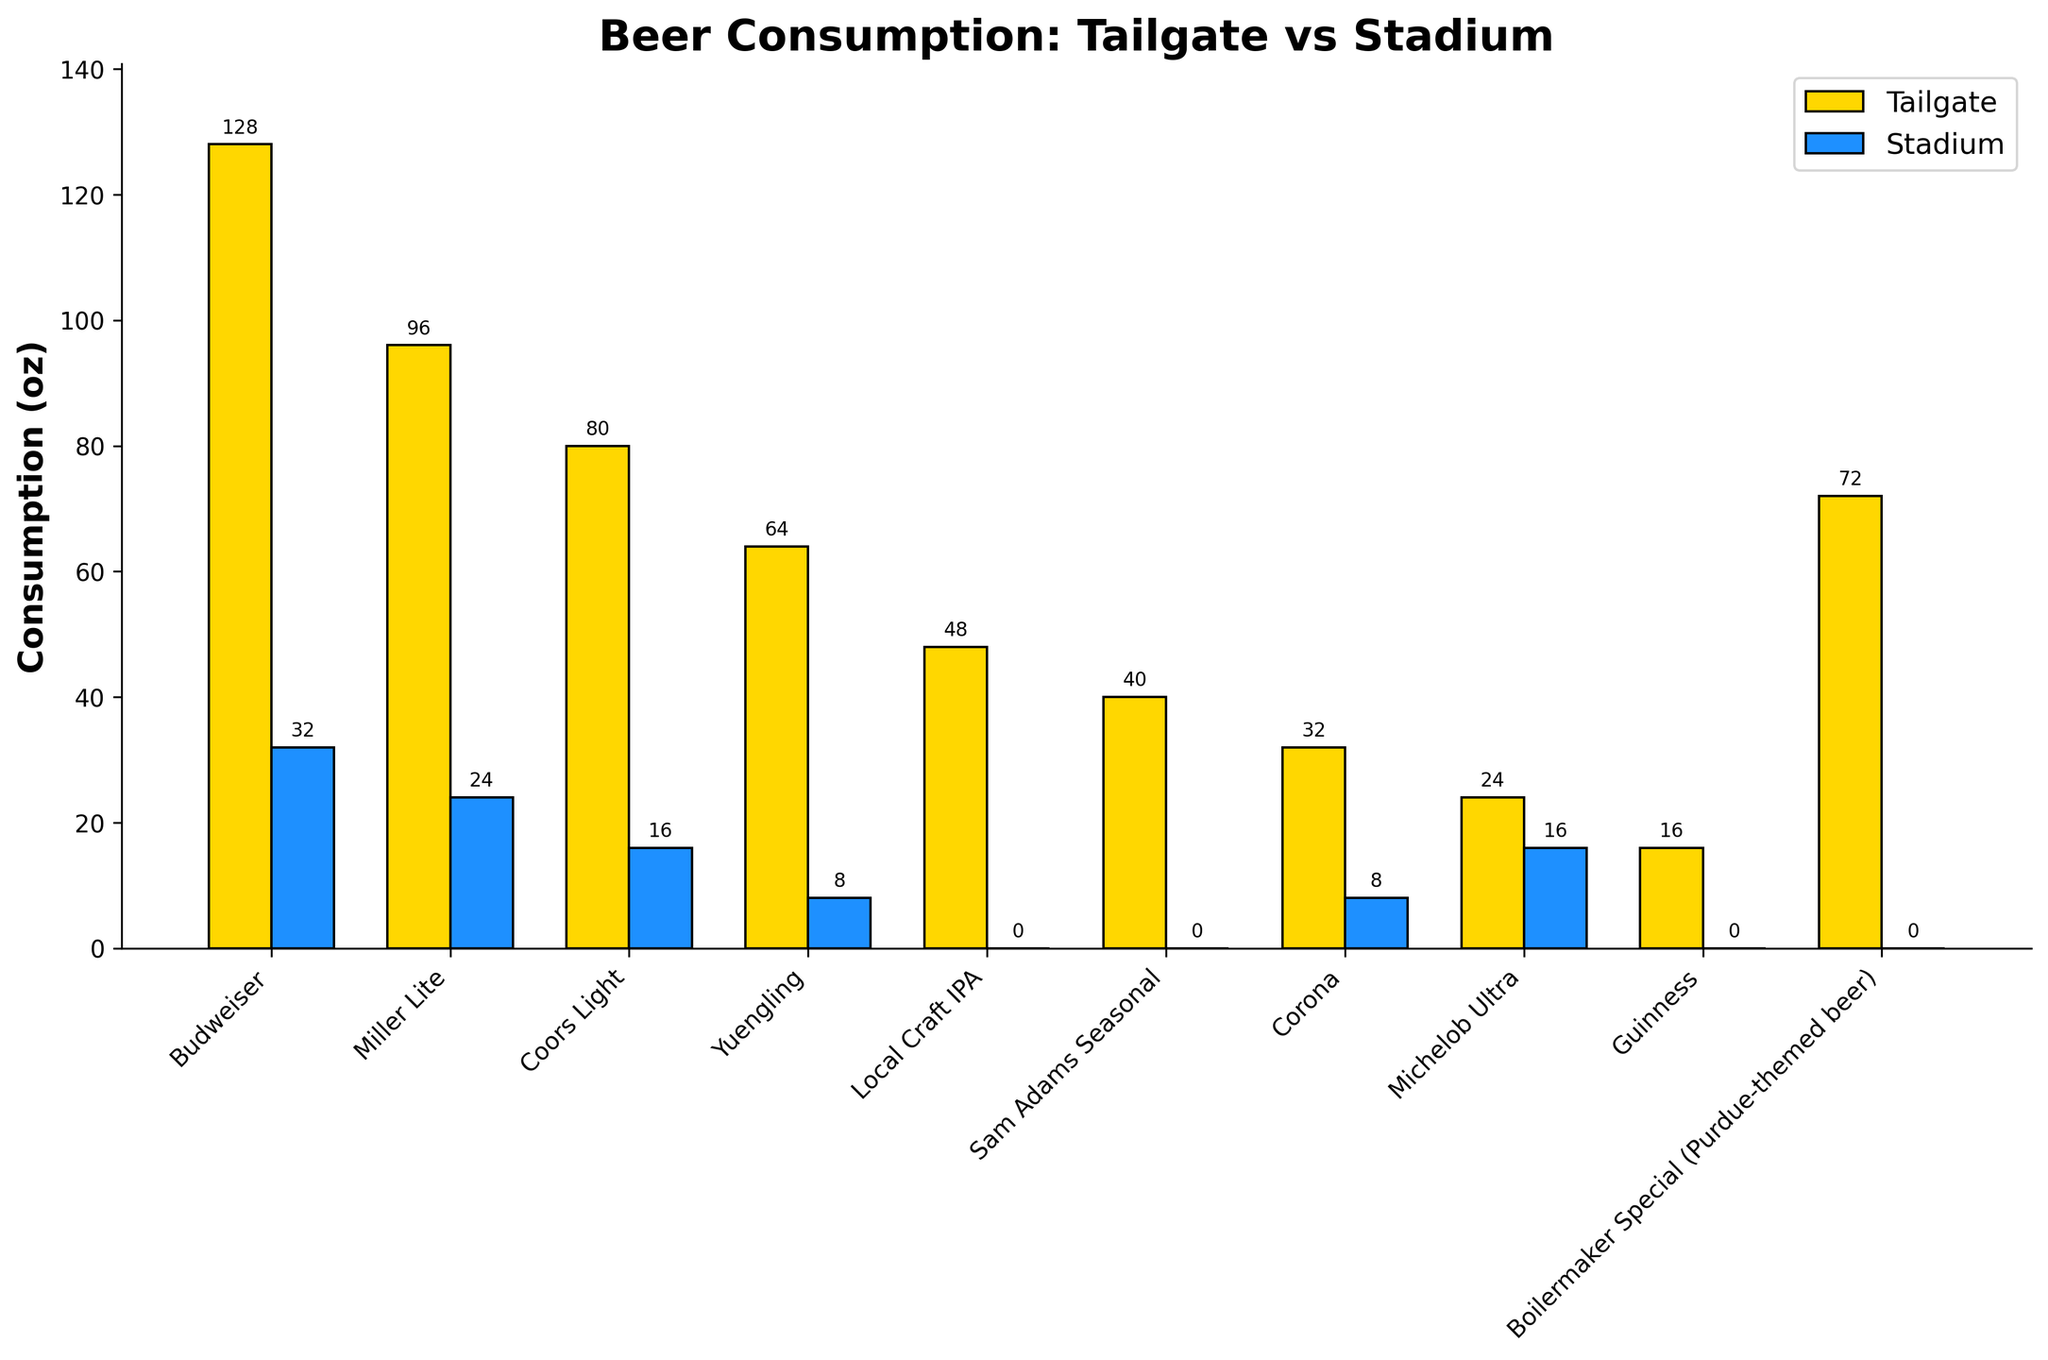What's the difference in consumption of Budweiser between tailgate and stadium? The tailgate consumption of Budweiser is 128 oz while the stadium consumption is 32 oz. The difference is 128 - 32 = 96 oz.
Answer: 96 oz Which beer type has the highest consumption at the tailgate? By observing the heights of the yellow bars representing tailgate consumption, Budweiser has the highest bar with 128 oz.
Answer: Budweiser Which beer has no consumption at the stadium? Beers with blue bars of zero height indicate no stadium consumption. The beers are Local Craft IPA, Sam Adams Seasonal, Guinness, and Boilermaker Special (Purdue-themed beer).
Answer: Local Craft IPA, Sam Adams Seasonal, Guinness, Boilermaker Special How many beers have a higher tailgate consumption than stadium consumption? Counting the beers where the yellow bar (tailgate) is taller than the blue bar (stadium), there are 9 out of 10 beers. Only Michelob Ultra does not fulfill this condition.
Answer: 9 What's the total consumption of Coors Light in both tailgate and stadium? The tailgate consumption of Coors Light is 80 oz, and the stadium consumption is 16 oz. Therefore, the total consumption is 80 + 16 = 96 oz.
Answer: 96 oz Which beer has a consumption of 24 oz at the tailgate? By observing the heights of the yellow bars, Michelob Ultra has a tailgate consumption of 24 oz.
Answer: Michelob Ultra Is there any beer consumed equally at the tailgate and stadium? Comparing the heights of the yellow and blue bars for all beer types, no beer has equal consumption in both tailgate and stadium.
Answer: No Which beer types have their stadium consumption more than 20 oz? By observing the blue bars, only Budweiser and Miller Lite have a stadium consumption above 20 oz, at 32 oz and 24 oz respectively.
Answer: Budweiser, Miller Lite What is the average tailgate consumption of beer types starting with the letter 'C'? The beer types starting with 'C' are Coors Light, Corona. Their tailgate consumptions are 80 oz and 32 oz respectively. The average is (80 + 32) / 2 = 56 oz.
Answer: 56 oz 